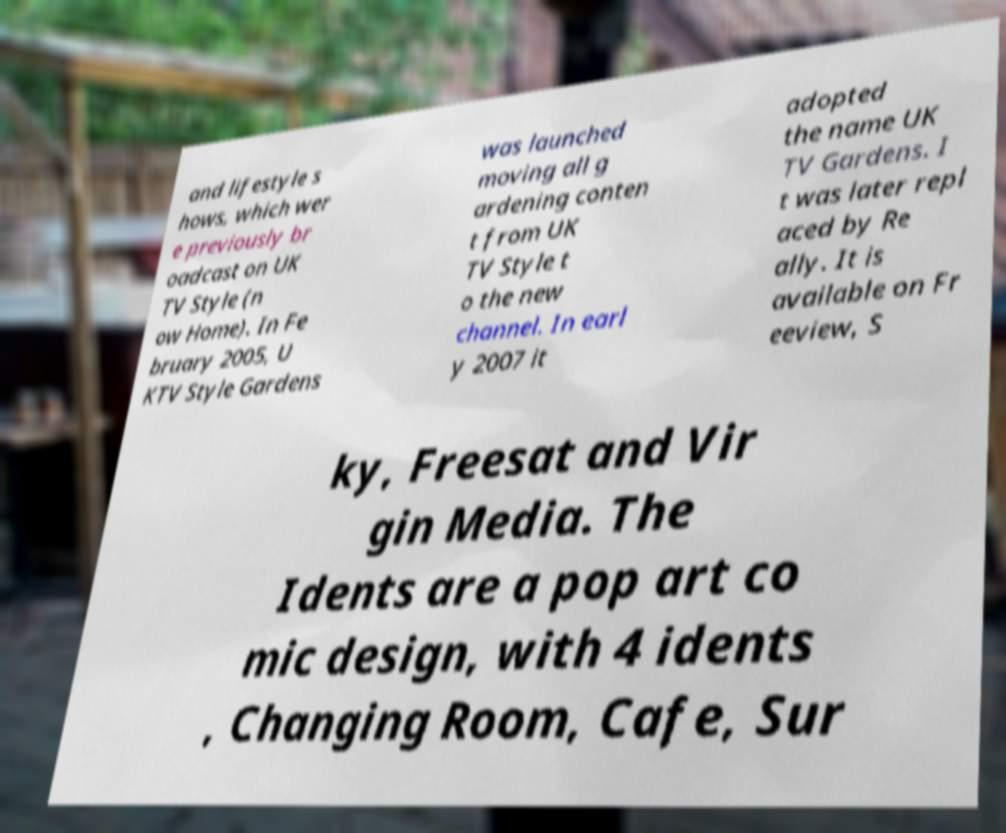Can you read and provide the text displayed in the image?This photo seems to have some interesting text. Can you extract and type it out for me? and lifestyle s hows, which wer e previously br oadcast on UK TV Style (n ow Home). In Fe bruary 2005, U KTV Style Gardens was launched moving all g ardening conten t from UK TV Style t o the new channel. In earl y 2007 it adopted the name UK TV Gardens. I t was later repl aced by Re ally. It is available on Fr eeview, S ky, Freesat and Vir gin Media. The Idents are a pop art co mic design, with 4 idents , Changing Room, Cafe, Sur 